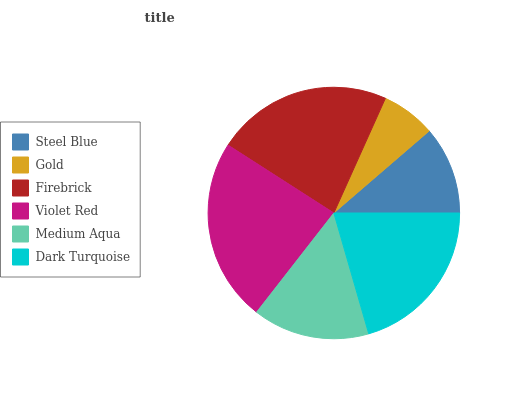Is Gold the minimum?
Answer yes or no. Yes. Is Violet Red the maximum?
Answer yes or no. Yes. Is Firebrick the minimum?
Answer yes or no. No. Is Firebrick the maximum?
Answer yes or no. No. Is Firebrick greater than Gold?
Answer yes or no. Yes. Is Gold less than Firebrick?
Answer yes or no. Yes. Is Gold greater than Firebrick?
Answer yes or no. No. Is Firebrick less than Gold?
Answer yes or no. No. Is Dark Turquoise the high median?
Answer yes or no. Yes. Is Medium Aqua the low median?
Answer yes or no. Yes. Is Medium Aqua the high median?
Answer yes or no. No. Is Firebrick the low median?
Answer yes or no. No. 